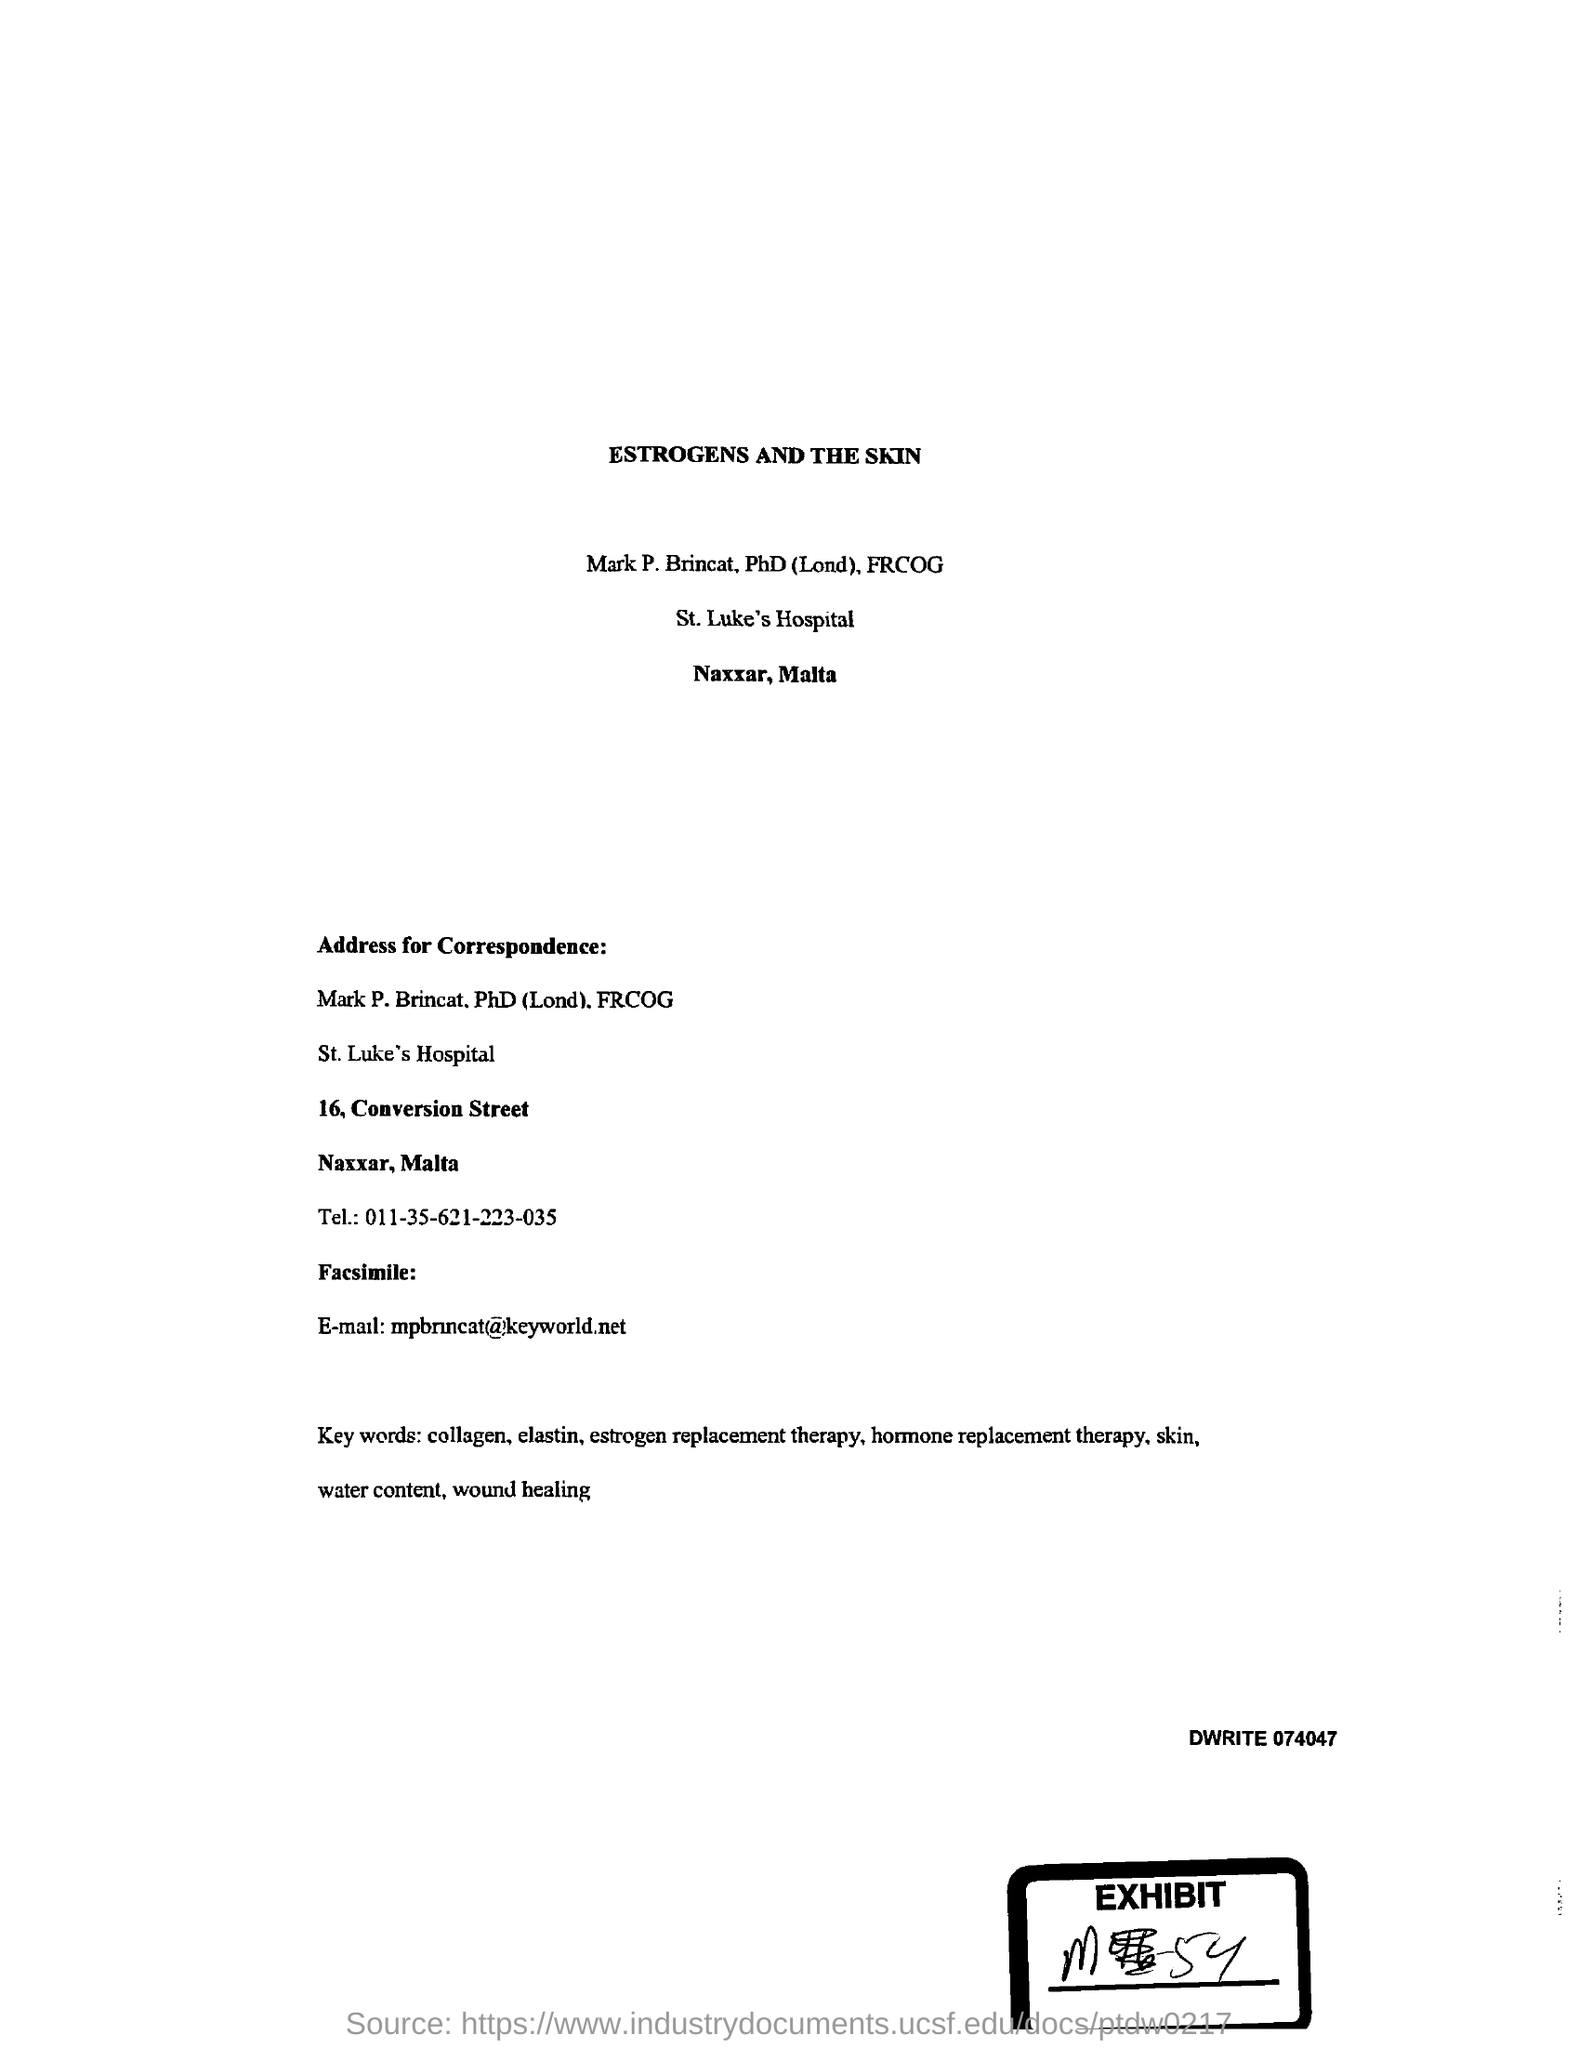What is the title of the document?
Offer a very short reply. Estrogens and the skin. What is the name of the hospital?
Give a very brief answer. St. Luke's Hospital. What is the telephone number?
Give a very brief answer. 011-35-621223-035. What is the Email id?
Ensure brevity in your answer.  Mpbrincat@keyworld.net. 